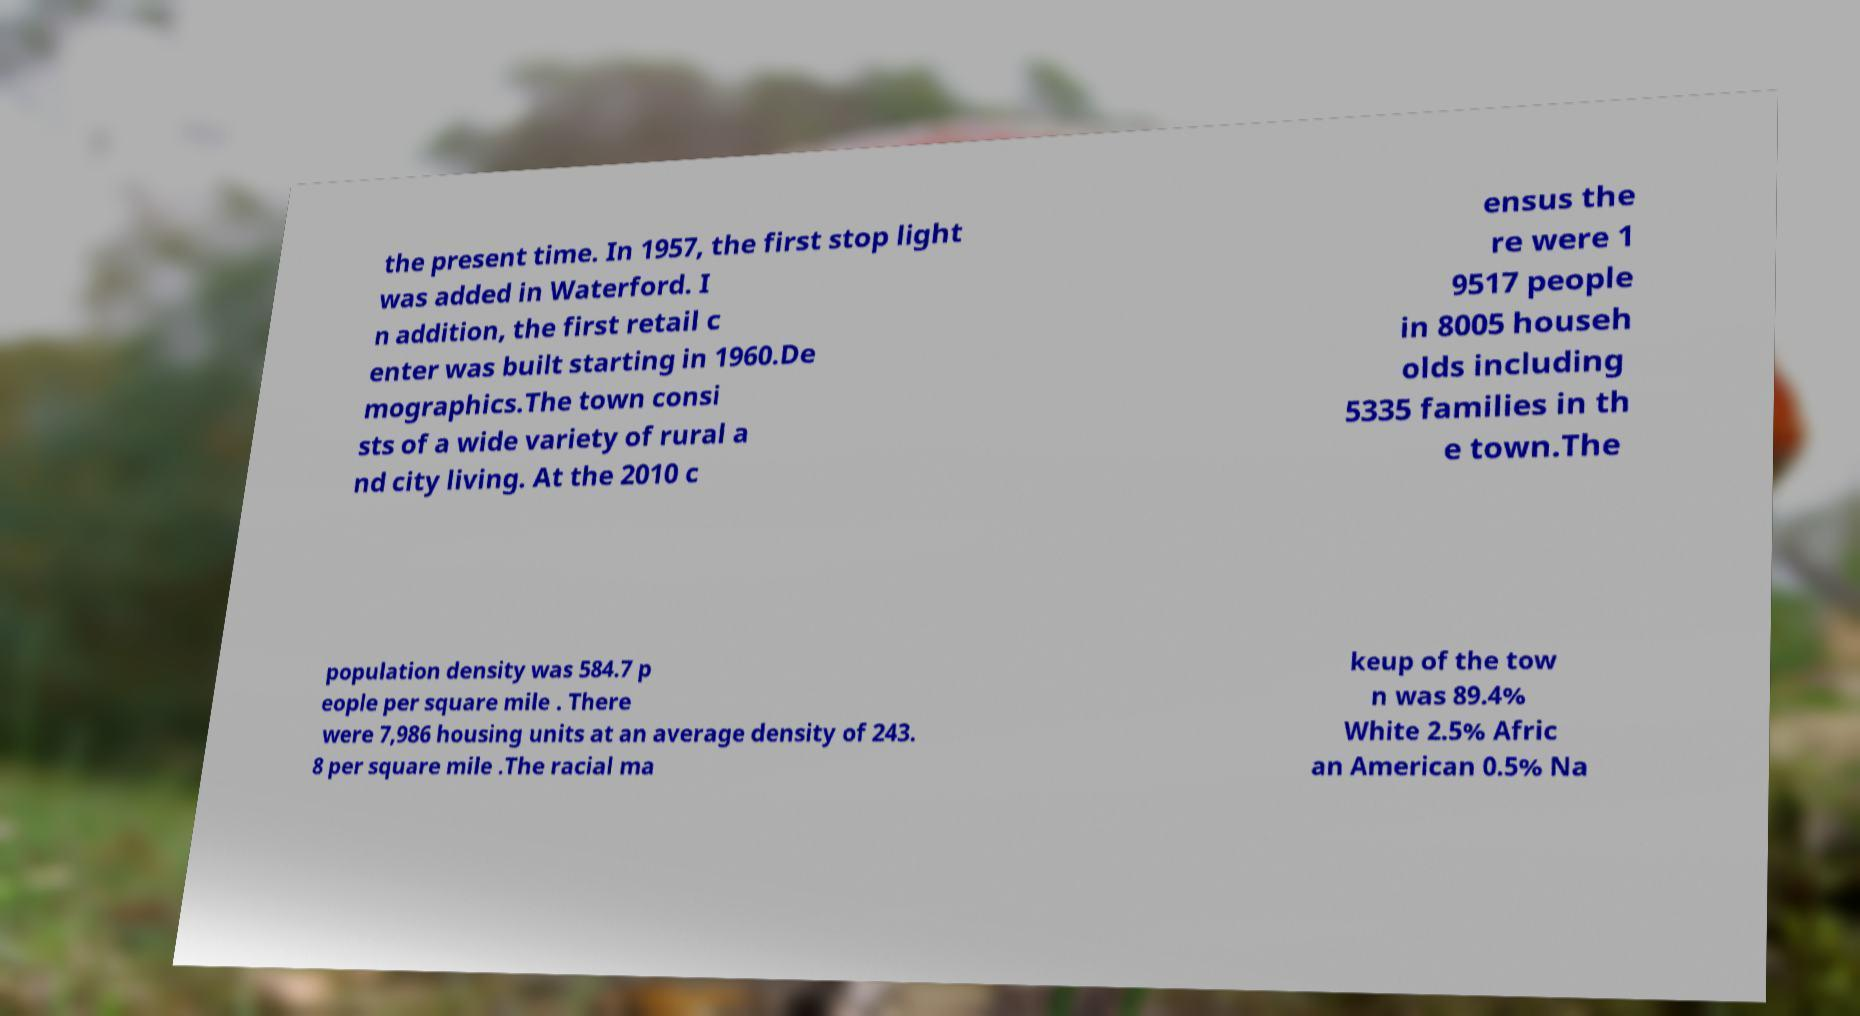There's text embedded in this image that I need extracted. Can you transcribe it verbatim? the present time. In 1957, the first stop light was added in Waterford. I n addition, the first retail c enter was built starting in 1960.De mographics.The town consi sts of a wide variety of rural a nd city living. At the 2010 c ensus the re were 1 9517 people in 8005 househ olds including 5335 families in th e town.The population density was 584.7 p eople per square mile . There were 7,986 housing units at an average density of 243. 8 per square mile .The racial ma keup of the tow n was 89.4% White 2.5% Afric an American 0.5% Na 